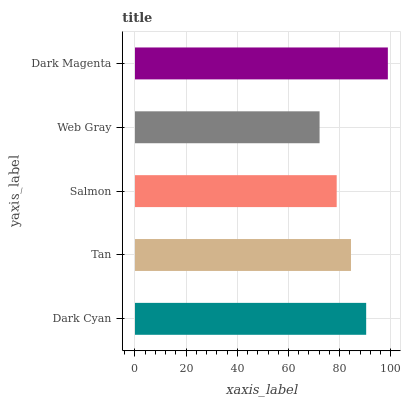Is Web Gray the minimum?
Answer yes or no. Yes. Is Dark Magenta the maximum?
Answer yes or no. Yes. Is Tan the minimum?
Answer yes or no. No. Is Tan the maximum?
Answer yes or no. No. Is Dark Cyan greater than Tan?
Answer yes or no. Yes. Is Tan less than Dark Cyan?
Answer yes or no. Yes. Is Tan greater than Dark Cyan?
Answer yes or no. No. Is Dark Cyan less than Tan?
Answer yes or no. No. Is Tan the high median?
Answer yes or no. Yes. Is Tan the low median?
Answer yes or no. Yes. Is Salmon the high median?
Answer yes or no. No. Is Web Gray the low median?
Answer yes or no. No. 